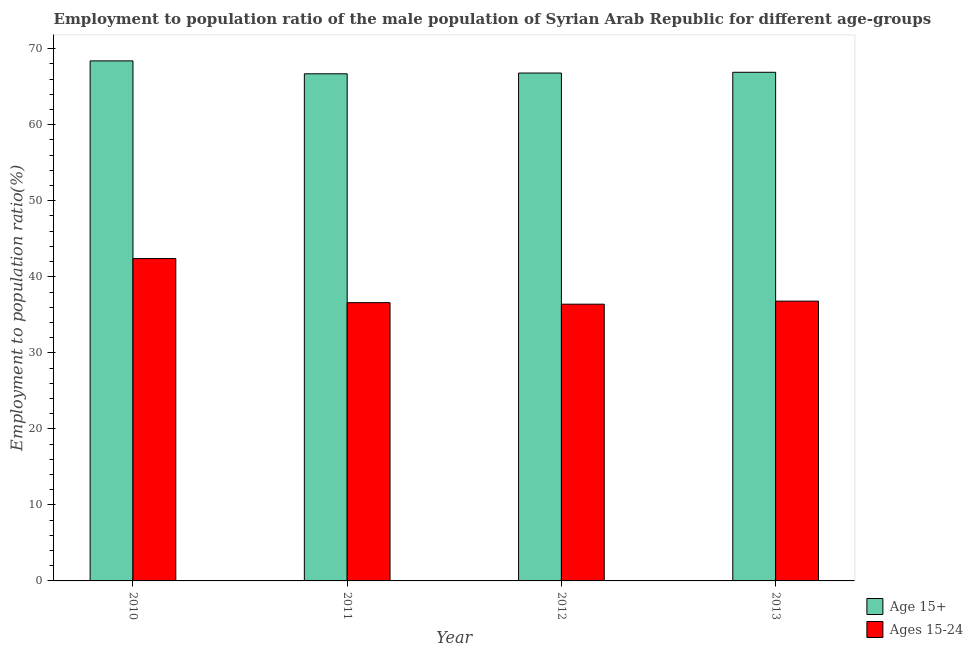How many groups of bars are there?
Your response must be concise. 4. What is the label of the 2nd group of bars from the left?
Make the answer very short. 2011. In how many cases, is the number of bars for a given year not equal to the number of legend labels?
Offer a very short reply. 0. What is the employment to population ratio(age 15+) in 2010?
Your answer should be very brief. 68.4. Across all years, what is the maximum employment to population ratio(age 15+)?
Provide a succinct answer. 68.4. Across all years, what is the minimum employment to population ratio(age 15+)?
Ensure brevity in your answer.  66.7. In which year was the employment to population ratio(age 15+) minimum?
Your answer should be compact. 2011. What is the total employment to population ratio(age 15+) in the graph?
Offer a very short reply. 268.8. What is the difference between the employment to population ratio(age 15-24) in 2010 and that in 2013?
Offer a very short reply. 5.6. What is the difference between the employment to population ratio(age 15-24) in 2011 and the employment to population ratio(age 15+) in 2012?
Make the answer very short. 0.2. What is the average employment to population ratio(age 15+) per year?
Offer a very short reply. 67.2. What is the ratio of the employment to population ratio(age 15+) in 2010 to that in 2012?
Your answer should be very brief. 1.02. Is the employment to population ratio(age 15+) in 2010 less than that in 2011?
Provide a succinct answer. No. What is the difference between the highest and the second highest employment to population ratio(age 15+)?
Offer a very short reply. 1.5. What is the difference between the highest and the lowest employment to population ratio(age 15+)?
Offer a terse response. 1.7. In how many years, is the employment to population ratio(age 15+) greater than the average employment to population ratio(age 15+) taken over all years?
Offer a very short reply. 1. Is the sum of the employment to population ratio(age 15+) in 2010 and 2011 greater than the maximum employment to population ratio(age 15-24) across all years?
Your answer should be compact. Yes. What does the 2nd bar from the left in 2012 represents?
Your answer should be very brief. Ages 15-24. What does the 2nd bar from the right in 2012 represents?
Your response must be concise. Age 15+. How many bars are there?
Your response must be concise. 8. Are all the bars in the graph horizontal?
Give a very brief answer. No. What is the difference between two consecutive major ticks on the Y-axis?
Your answer should be compact. 10. Are the values on the major ticks of Y-axis written in scientific E-notation?
Provide a succinct answer. No. Does the graph contain grids?
Your answer should be very brief. No. Where does the legend appear in the graph?
Offer a very short reply. Bottom right. How many legend labels are there?
Provide a short and direct response. 2. How are the legend labels stacked?
Provide a short and direct response. Vertical. What is the title of the graph?
Offer a very short reply. Employment to population ratio of the male population of Syrian Arab Republic for different age-groups. What is the label or title of the Y-axis?
Make the answer very short. Employment to population ratio(%). What is the Employment to population ratio(%) in Age 15+ in 2010?
Make the answer very short. 68.4. What is the Employment to population ratio(%) of Ages 15-24 in 2010?
Make the answer very short. 42.4. What is the Employment to population ratio(%) of Age 15+ in 2011?
Your response must be concise. 66.7. What is the Employment to population ratio(%) in Ages 15-24 in 2011?
Give a very brief answer. 36.6. What is the Employment to population ratio(%) of Age 15+ in 2012?
Your answer should be very brief. 66.8. What is the Employment to population ratio(%) in Ages 15-24 in 2012?
Your answer should be very brief. 36.4. What is the Employment to population ratio(%) in Age 15+ in 2013?
Provide a short and direct response. 66.9. What is the Employment to population ratio(%) in Ages 15-24 in 2013?
Provide a succinct answer. 36.8. Across all years, what is the maximum Employment to population ratio(%) of Age 15+?
Make the answer very short. 68.4. Across all years, what is the maximum Employment to population ratio(%) of Ages 15-24?
Offer a very short reply. 42.4. Across all years, what is the minimum Employment to population ratio(%) in Age 15+?
Make the answer very short. 66.7. Across all years, what is the minimum Employment to population ratio(%) of Ages 15-24?
Provide a short and direct response. 36.4. What is the total Employment to population ratio(%) in Age 15+ in the graph?
Your answer should be very brief. 268.8. What is the total Employment to population ratio(%) in Ages 15-24 in the graph?
Offer a very short reply. 152.2. What is the difference between the Employment to population ratio(%) in Ages 15-24 in 2010 and that in 2011?
Your answer should be compact. 5.8. What is the difference between the Employment to population ratio(%) of Ages 15-24 in 2010 and that in 2013?
Provide a short and direct response. 5.6. What is the difference between the Employment to population ratio(%) in Age 15+ in 2011 and that in 2012?
Your response must be concise. -0.1. What is the difference between the Employment to population ratio(%) of Ages 15-24 in 2011 and that in 2012?
Offer a terse response. 0.2. What is the difference between the Employment to population ratio(%) of Age 15+ in 2011 and that in 2013?
Provide a short and direct response. -0.2. What is the difference between the Employment to population ratio(%) in Age 15+ in 2010 and the Employment to population ratio(%) in Ages 15-24 in 2011?
Your answer should be compact. 31.8. What is the difference between the Employment to population ratio(%) in Age 15+ in 2010 and the Employment to population ratio(%) in Ages 15-24 in 2013?
Your response must be concise. 31.6. What is the difference between the Employment to population ratio(%) of Age 15+ in 2011 and the Employment to population ratio(%) of Ages 15-24 in 2012?
Provide a short and direct response. 30.3. What is the difference between the Employment to population ratio(%) in Age 15+ in 2011 and the Employment to population ratio(%) in Ages 15-24 in 2013?
Offer a very short reply. 29.9. What is the difference between the Employment to population ratio(%) of Age 15+ in 2012 and the Employment to population ratio(%) of Ages 15-24 in 2013?
Give a very brief answer. 30. What is the average Employment to population ratio(%) of Age 15+ per year?
Provide a succinct answer. 67.2. What is the average Employment to population ratio(%) of Ages 15-24 per year?
Your answer should be compact. 38.05. In the year 2010, what is the difference between the Employment to population ratio(%) in Age 15+ and Employment to population ratio(%) in Ages 15-24?
Offer a very short reply. 26. In the year 2011, what is the difference between the Employment to population ratio(%) in Age 15+ and Employment to population ratio(%) in Ages 15-24?
Ensure brevity in your answer.  30.1. In the year 2012, what is the difference between the Employment to population ratio(%) of Age 15+ and Employment to population ratio(%) of Ages 15-24?
Make the answer very short. 30.4. In the year 2013, what is the difference between the Employment to population ratio(%) of Age 15+ and Employment to population ratio(%) of Ages 15-24?
Provide a succinct answer. 30.1. What is the ratio of the Employment to population ratio(%) in Age 15+ in 2010 to that in 2011?
Offer a terse response. 1.03. What is the ratio of the Employment to population ratio(%) in Ages 15-24 in 2010 to that in 2011?
Your response must be concise. 1.16. What is the ratio of the Employment to population ratio(%) in Ages 15-24 in 2010 to that in 2012?
Offer a very short reply. 1.16. What is the ratio of the Employment to population ratio(%) in Age 15+ in 2010 to that in 2013?
Offer a terse response. 1.02. What is the ratio of the Employment to population ratio(%) of Ages 15-24 in 2010 to that in 2013?
Offer a terse response. 1.15. What is the ratio of the Employment to population ratio(%) of Age 15+ in 2011 to that in 2012?
Offer a very short reply. 1. What is the ratio of the Employment to population ratio(%) of Age 15+ in 2011 to that in 2013?
Give a very brief answer. 1. What is the ratio of the Employment to population ratio(%) of Ages 15-24 in 2012 to that in 2013?
Provide a succinct answer. 0.99. What is the difference between the highest and the second highest Employment to population ratio(%) of Ages 15-24?
Your response must be concise. 5.6. 